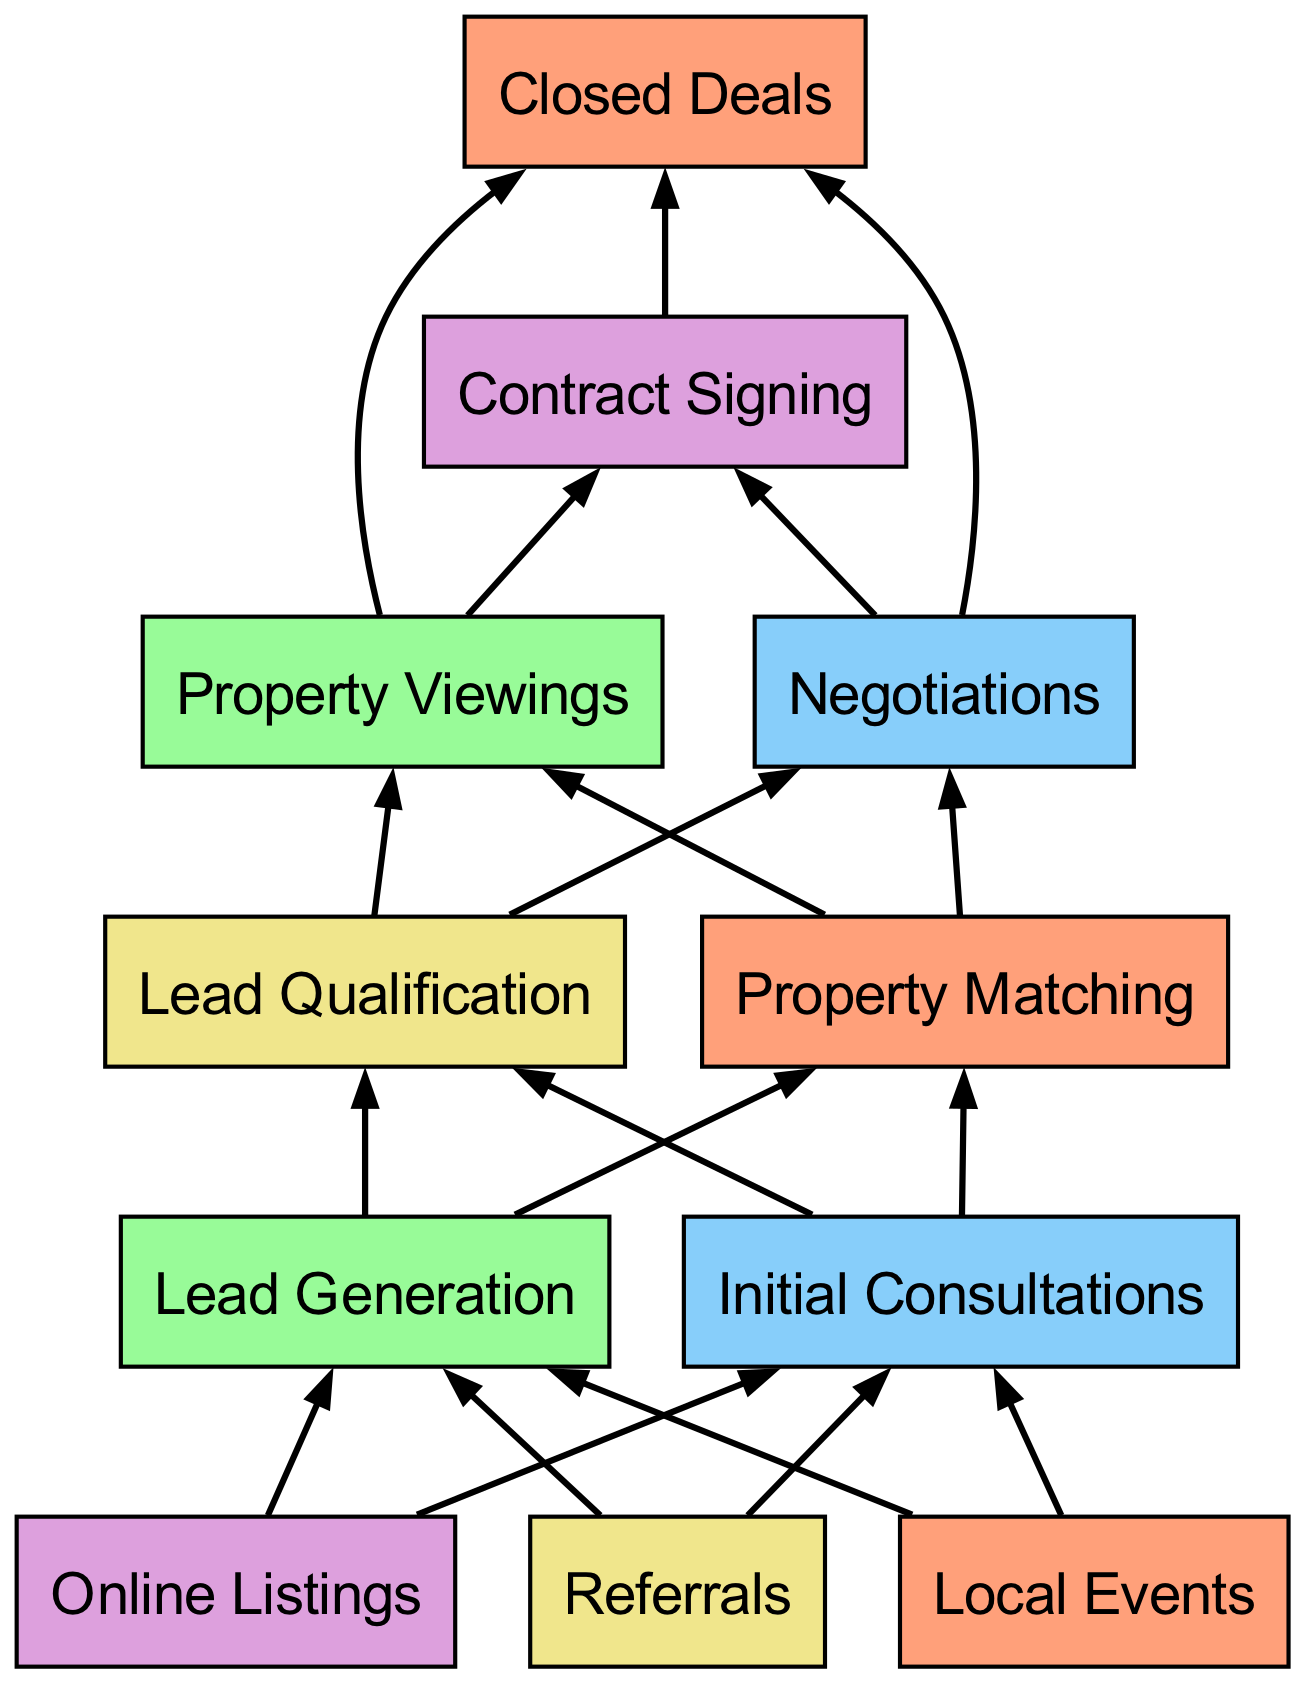What is the final output of the acquisition process? The final output shown in the diagram is "Closed Deals," which is represented at the top of the flowchart. This node signifies the completed transactions as a result of the entire client acquisition funnel.
Answer: Closed Deals How many connections does "Lead Generation" have? In the diagram, "Lead Generation" has three connections to other nodes: "Online Listings," "Referrals," and "Local Events." This means it has multiple pathways leading to the next stages.
Answer: 3 What leads to "Property Viewings"? The node "Property Viewings" is shown to be reached from two connections: "Contract Signing" and "Negotiations," according to the diagram's flow. These stages are vital for progressing towards the viewings.
Answer: Contract Signing and Negotiations Which nodes connect directly to "Lead Qualification"? "Lead Qualification" has two direct connections coming from "Property Viewings" and "Negotiations," establishing its role as a key step in the acquisition process.
Answer: Property Viewings and Negotiations Which node has connections to "Contract Signing"? The nodes that connect to "Contract Signing" are "Property Viewings" and "Negotiations," showing that these stages feed into the contract phase during client acquisition.
Answer: Property Viewings and Negotiations What is the immediate predecessor of "Negotiations"? "Negotiations" has two predecessors, one of which is "Contract Signing." This indicates that clients typically undergo contract reviews before negotiations begin.
Answer: Contract Signing Identify the node with no outgoing connections. The node "Online Listings" does not have any outgoing connections, which signifies that it serves as a standalone lead generation source without further steps emerging from it.
Answer: Online Listings How many nodes are in the diagram? By counting the nodes listed in the diagram, there is a total of 11 elements represented, detailing various stages of the client acquisition process.
Answer: 11 Which nodes lead to "Initial Consultations"? Both "Lead Generation" and "Lead Qualification" lead directly to "Initial Consultations," forming crucial steps for engaging potential clients.
Answer: Lead Generation and Lead Qualification What is the common function of the nodes "Referrals," "Local Events," and "Online Listings"? These three nodes, "Referrals," "Local Events," and "Online Listings," all serve the function of generating leads for the real estate agency as the initial stages of the client acquisition funnel.
Answer: Lead Generation 